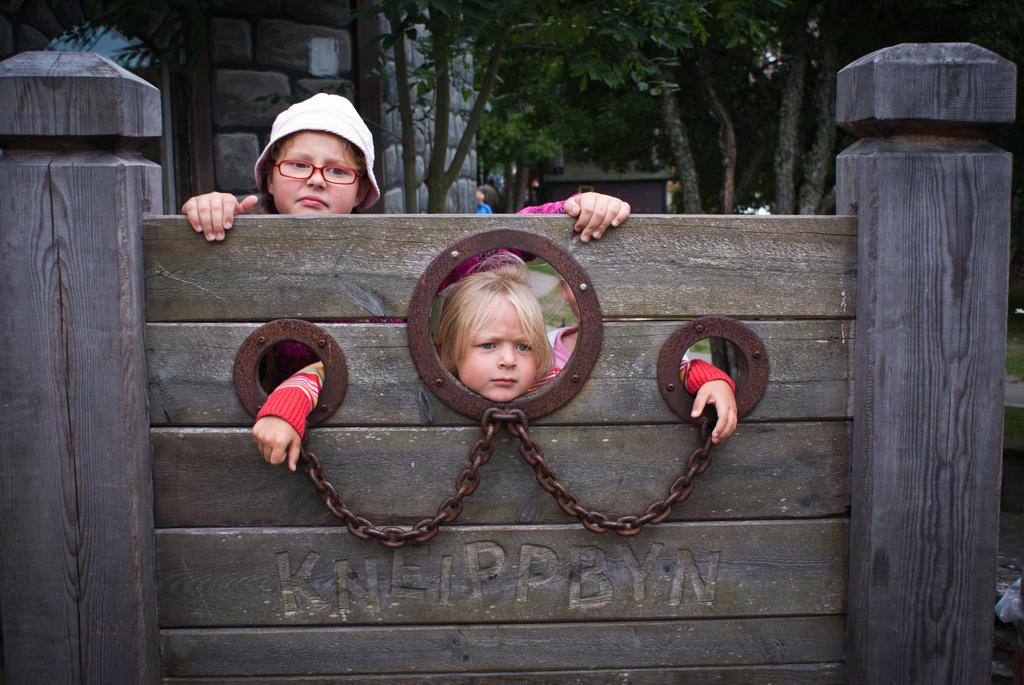What is on the wooden wall in the image? There is text on the wooden wall in the image. How many people are in the image? There are two people in the image. What can be seen in the background of the image? There are buildings and trees in the background of the image. What type of trousers is the appliance wearing in the image? There is no appliance or trousers present in the image. What role does the father play in the image? There is no father present in the image. 